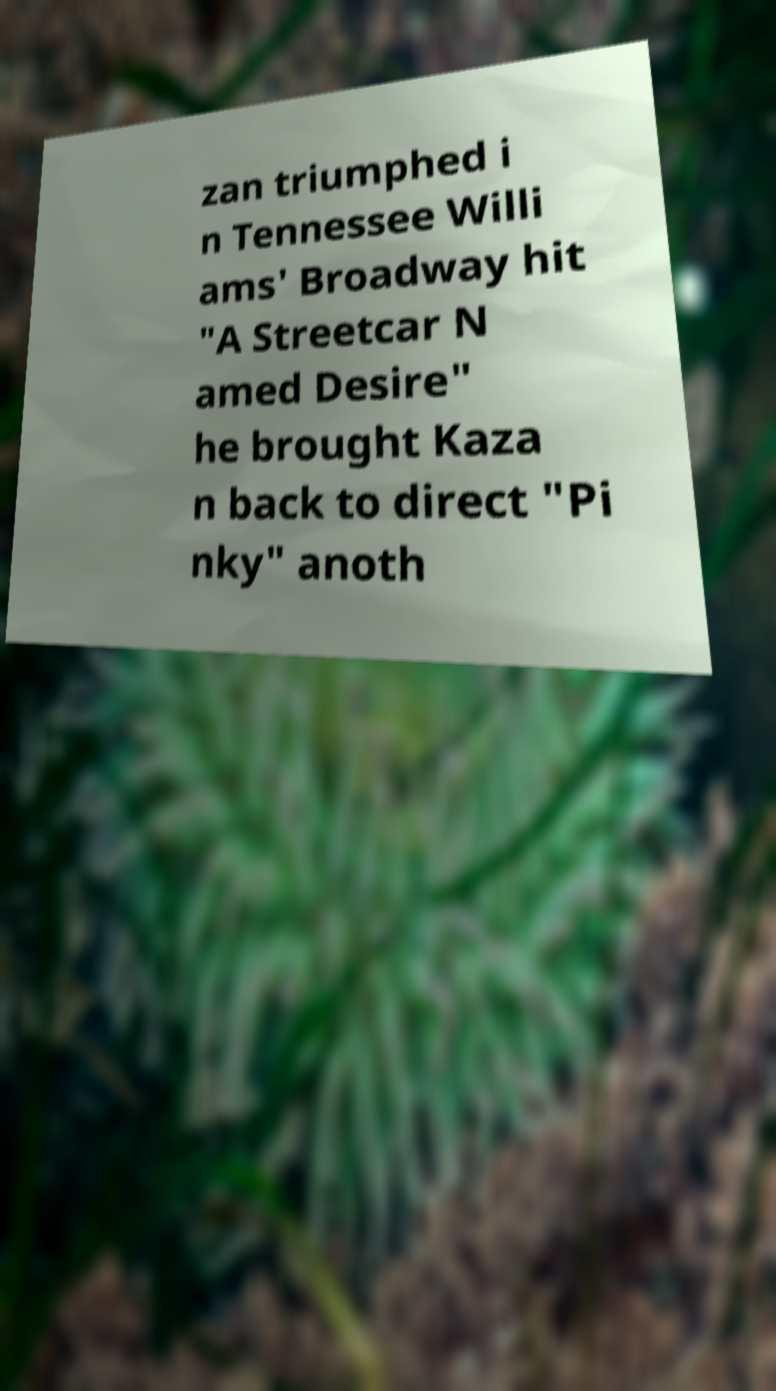What messages or text are displayed in this image? I need them in a readable, typed format. zan triumphed i n Tennessee Willi ams' Broadway hit "A Streetcar N amed Desire" he brought Kaza n back to direct "Pi nky" anoth 